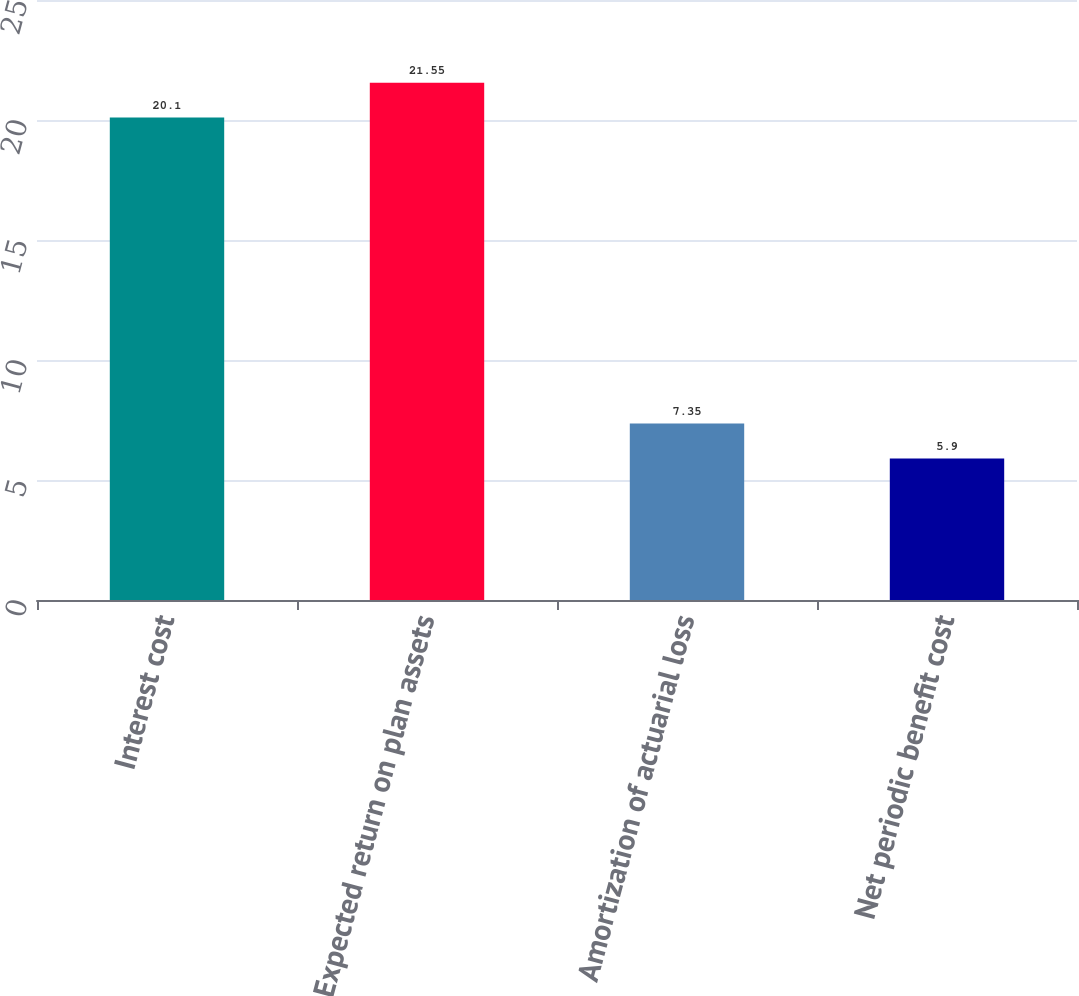Convert chart to OTSL. <chart><loc_0><loc_0><loc_500><loc_500><bar_chart><fcel>Interest cost<fcel>Expected return on plan assets<fcel>Amortization of actuarial loss<fcel>Net periodic benefit cost<nl><fcel>20.1<fcel>21.55<fcel>7.35<fcel>5.9<nl></chart> 